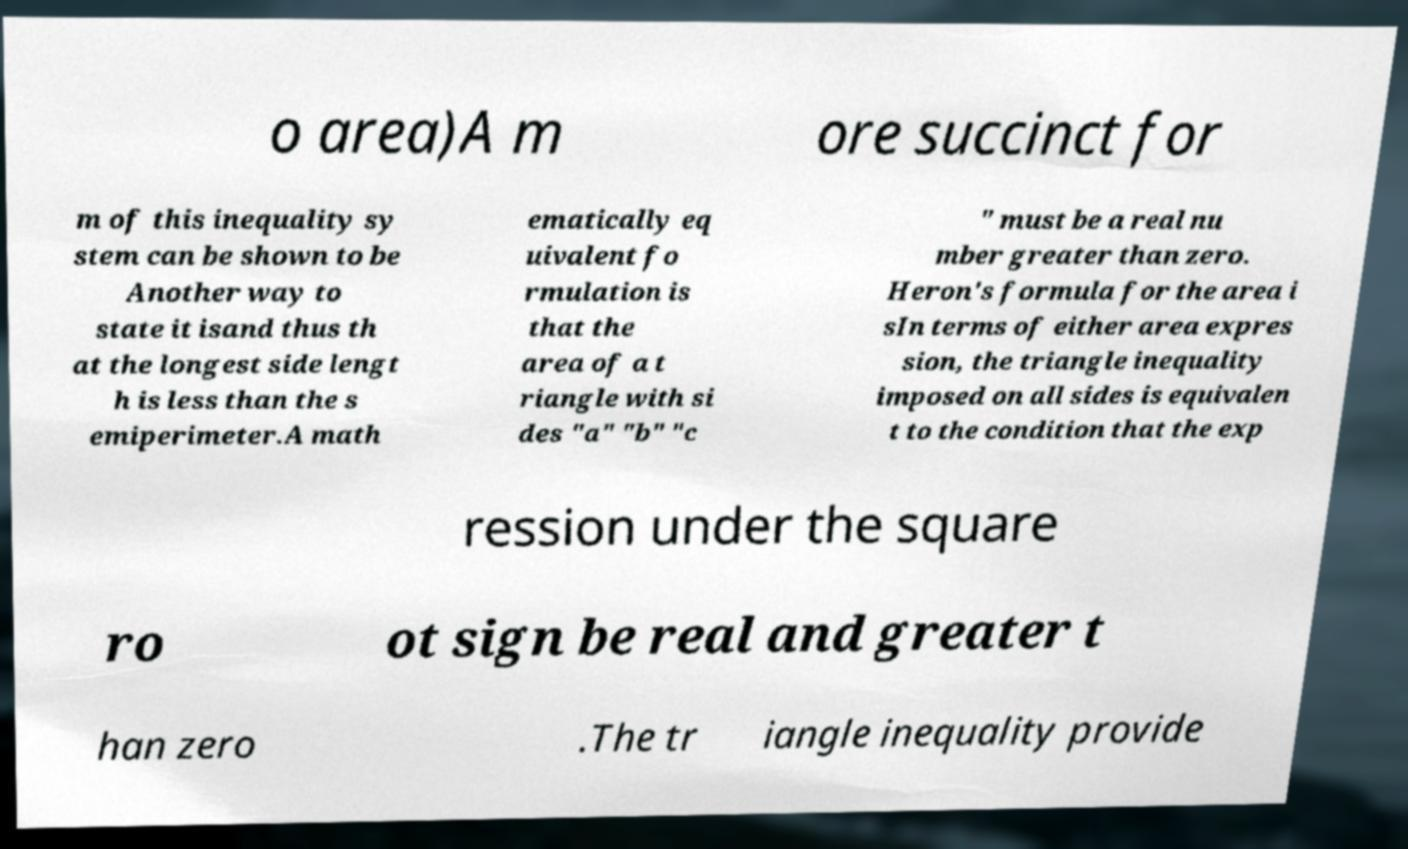I need the written content from this picture converted into text. Can you do that? o area)A m ore succinct for m of this inequality sy stem can be shown to be Another way to state it isand thus th at the longest side lengt h is less than the s emiperimeter.A math ematically eq uivalent fo rmulation is that the area of a t riangle with si des "a" "b" "c " must be a real nu mber greater than zero. Heron's formula for the area i sIn terms of either area expres sion, the triangle inequality imposed on all sides is equivalen t to the condition that the exp ression under the square ro ot sign be real and greater t han zero .The tr iangle inequality provide 